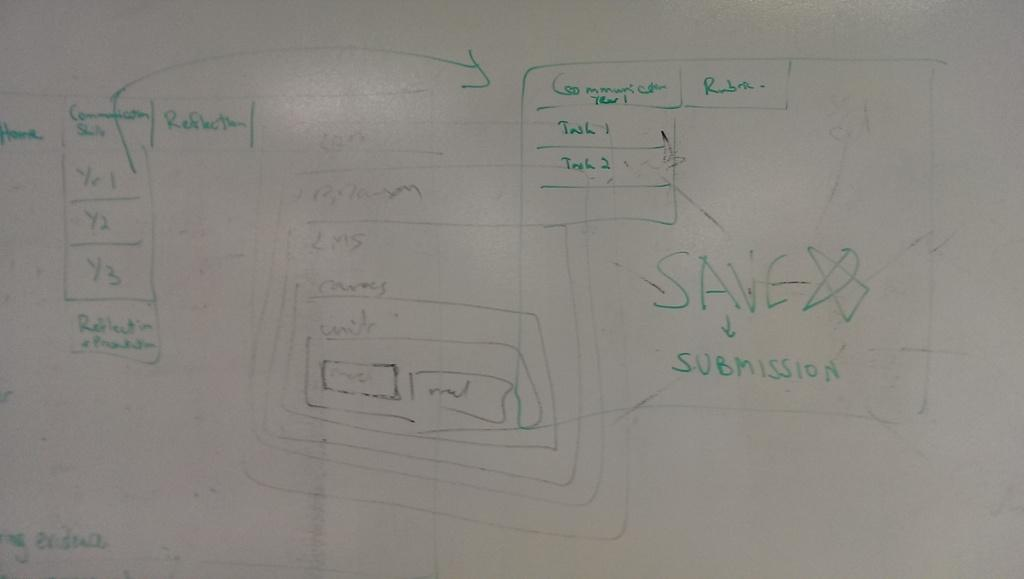<image>
Write a terse but informative summary of the picture. A white board has the word save on it in green letters. 